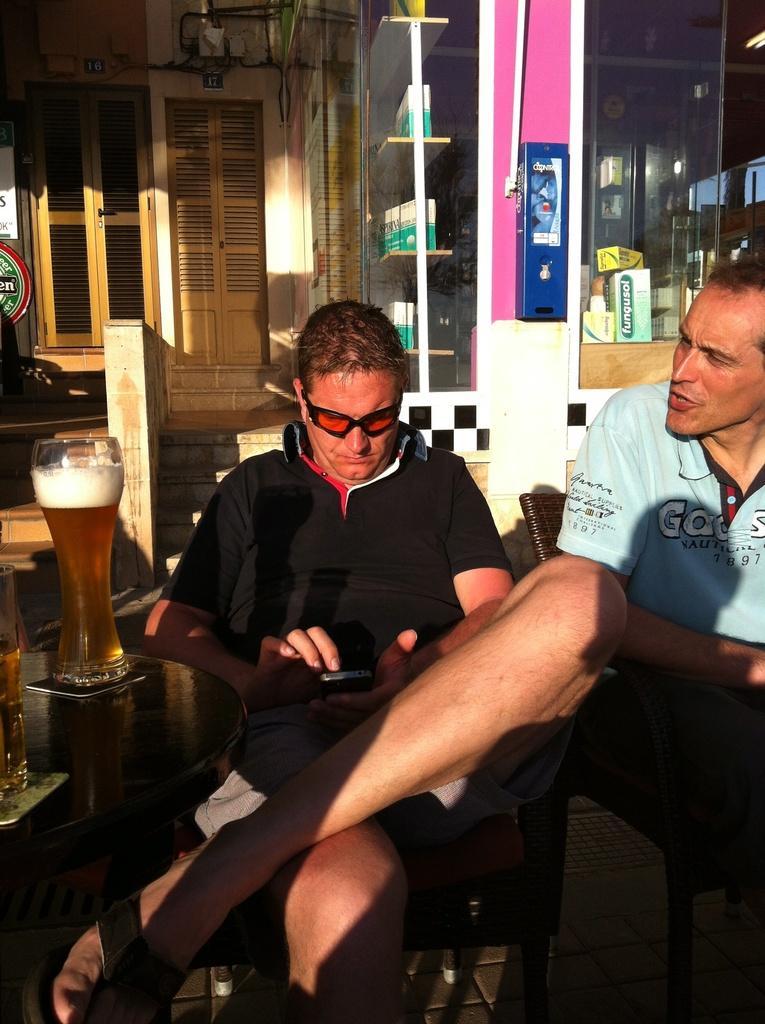Can you describe this image briefly? In the image there are two people,a man is sitting in front of a table,on the table there are two classes filled with drink he is operating mobile,to his right side another man is speaking to him,there is a lot of Sunlight,to the right side there is a store,in the background there is a wooden door. 